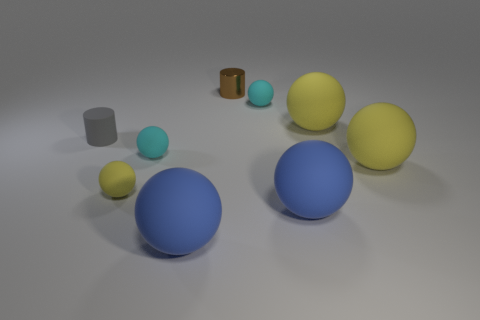What is the shape of the rubber thing on the left side of the yellow rubber object that is to the left of the tiny brown shiny cylinder?
Ensure brevity in your answer.  Cylinder. What number of yellow objects are either big rubber things or cylinders?
Your answer should be very brief. 2. There is a large rubber sphere that is behind the small cyan thing in front of the gray matte cylinder; are there any balls in front of it?
Your response must be concise. Yes. Are there any other things that are made of the same material as the small gray thing?
Your answer should be compact. Yes. What number of tiny objects are rubber things or blue spheres?
Your response must be concise. 4. Do the tiny yellow thing that is to the left of the brown thing and the tiny brown shiny thing have the same shape?
Offer a terse response. No. Are there fewer large yellow balls than yellow matte objects?
Your answer should be very brief. Yes. Is there anything else that is the same color as the tiny shiny cylinder?
Keep it short and to the point. No. There is a metallic thing to the right of the small matte cylinder; what shape is it?
Provide a succinct answer. Cylinder. There is a metal cylinder; does it have the same color as the cylinder that is to the left of the small yellow rubber ball?
Your answer should be compact. No. 